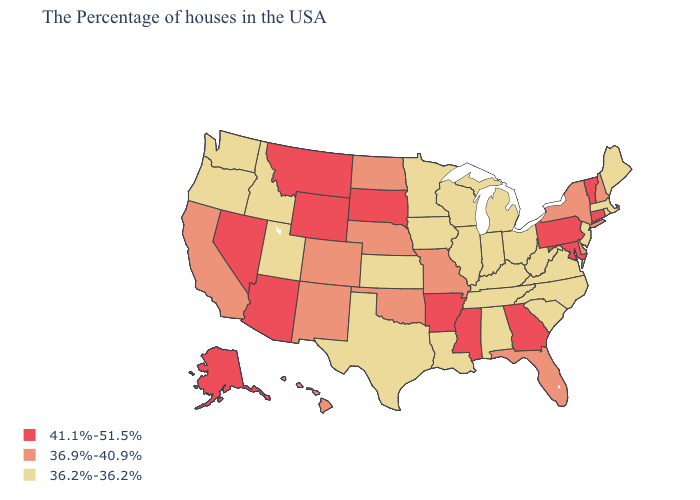What is the highest value in states that border Ohio?
Write a very short answer. 41.1%-51.5%. Does South Dakota have the highest value in the USA?
Keep it brief. Yes. What is the lowest value in the Northeast?
Write a very short answer. 36.2%-36.2%. Name the states that have a value in the range 36.2%-36.2%?
Be succinct. Maine, Massachusetts, Rhode Island, New Jersey, Virginia, North Carolina, South Carolina, West Virginia, Ohio, Michigan, Kentucky, Indiana, Alabama, Tennessee, Wisconsin, Illinois, Louisiana, Minnesota, Iowa, Kansas, Texas, Utah, Idaho, Washington, Oregon. What is the lowest value in the USA?
Answer briefly. 36.2%-36.2%. What is the value of Vermont?
Concise answer only. 41.1%-51.5%. Name the states that have a value in the range 41.1%-51.5%?
Write a very short answer. Vermont, Connecticut, Maryland, Pennsylvania, Georgia, Mississippi, Arkansas, South Dakota, Wyoming, Montana, Arizona, Nevada, Alaska. Name the states that have a value in the range 36.9%-40.9%?
Keep it brief. New Hampshire, New York, Delaware, Florida, Missouri, Nebraska, Oklahoma, North Dakota, Colorado, New Mexico, California, Hawaii. Does Pennsylvania have the same value as North Dakota?
Answer briefly. No. Among the states that border Texas , does Louisiana have the lowest value?
Write a very short answer. Yes. How many symbols are there in the legend?
Be succinct. 3. Does Kansas have a lower value than Louisiana?
Keep it brief. No. Name the states that have a value in the range 41.1%-51.5%?
Concise answer only. Vermont, Connecticut, Maryland, Pennsylvania, Georgia, Mississippi, Arkansas, South Dakota, Wyoming, Montana, Arizona, Nevada, Alaska. What is the lowest value in the MidWest?
Quick response, please. 36.2%-36.2%. Which states hav the highest value in the Northeast?
Write a very short answer. Vermont, Connecticut, Pennsylvania. 